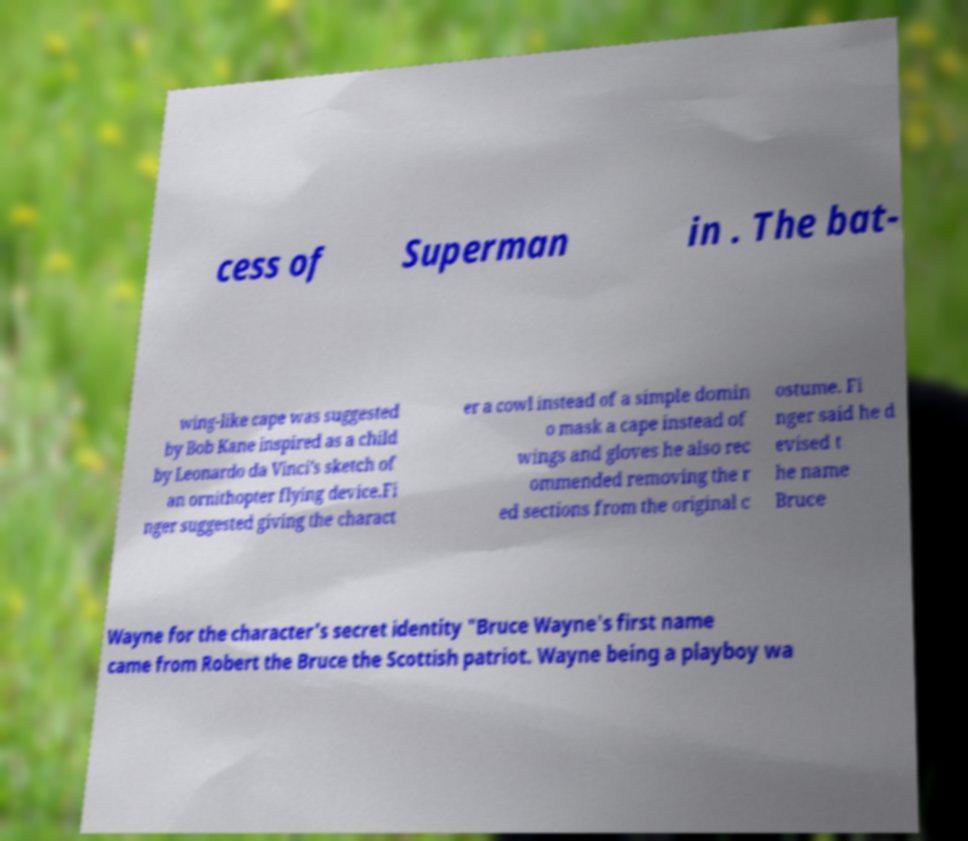There's text embedded in this image that I need extracted. Can you transcribe it verbatim? cess of Superman in . The bat- wing-like cape was suggested by Bob Kane inspired as a child by Leonardo da Vinci's sketch of an ornithopter flying device.Fi nger suggested giving the charact er a cowl instead of a simple domin o mask a cape instead of wings and gloves he also rec ommended removing the r ed sections from the original c ostume. Fi nger said he d evised t he name Bruce Wayne for the character's secret identity "Bruce Wayne's first name came from Robert the Bruce the Scottish patriot. Wayne being a playboy wa 